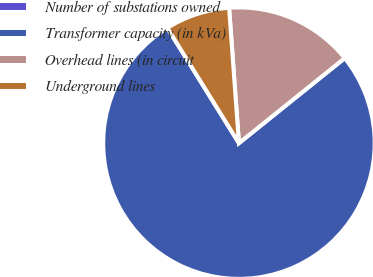Convert chart to OTSL. <chart><loc_0><loc_0><loc_500><loc_500><pie_chart><fcel>Number of substations owned<fcel>Transformer capacity (in kVa)<fcel>Overhead lines (in circuit<fcel>Underground lines<nl><fcel>0.0%<fcel>76.92%<fcel>15.38%<fcel>7.69%<nl></chart> 